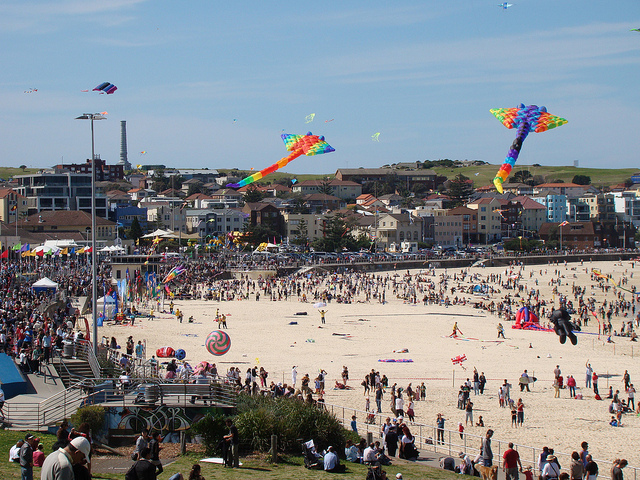<image>What are the two brightly colored kites shaped to represent? I am not certain. The brightly colored kites could be shaped to represent various things such as stingrays, birds, planes, or even a dragon. What are the two brightly colored kites shaped to represent? I am not sure what the two brightly colored kites are shaped to represent. They can be shaped like stingrays, planes, birds, or dragon. 